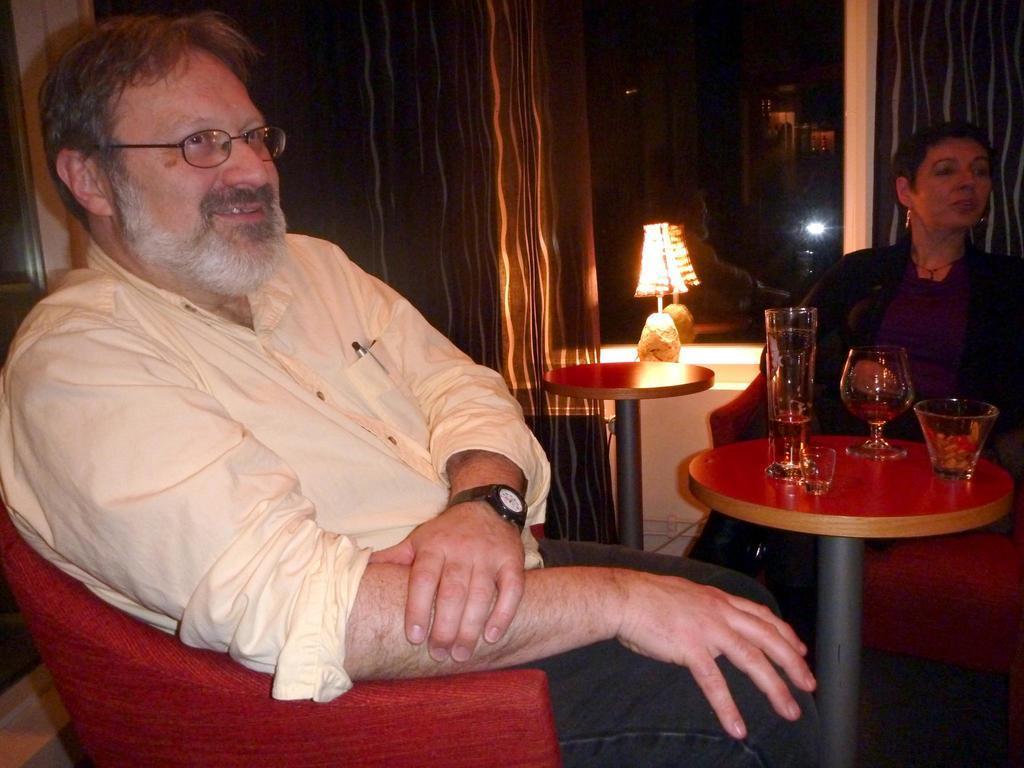How would you summarize this image in a sentence or two? Man in yellow shirt who is wearing spectacles is sitting on red chair. In front of him, we see a table on which glass containing liquid and bowl are placed. Beside that, woman in black dress is sitting on sofa and on background, we see lamp and curtains. We even see mirror. 